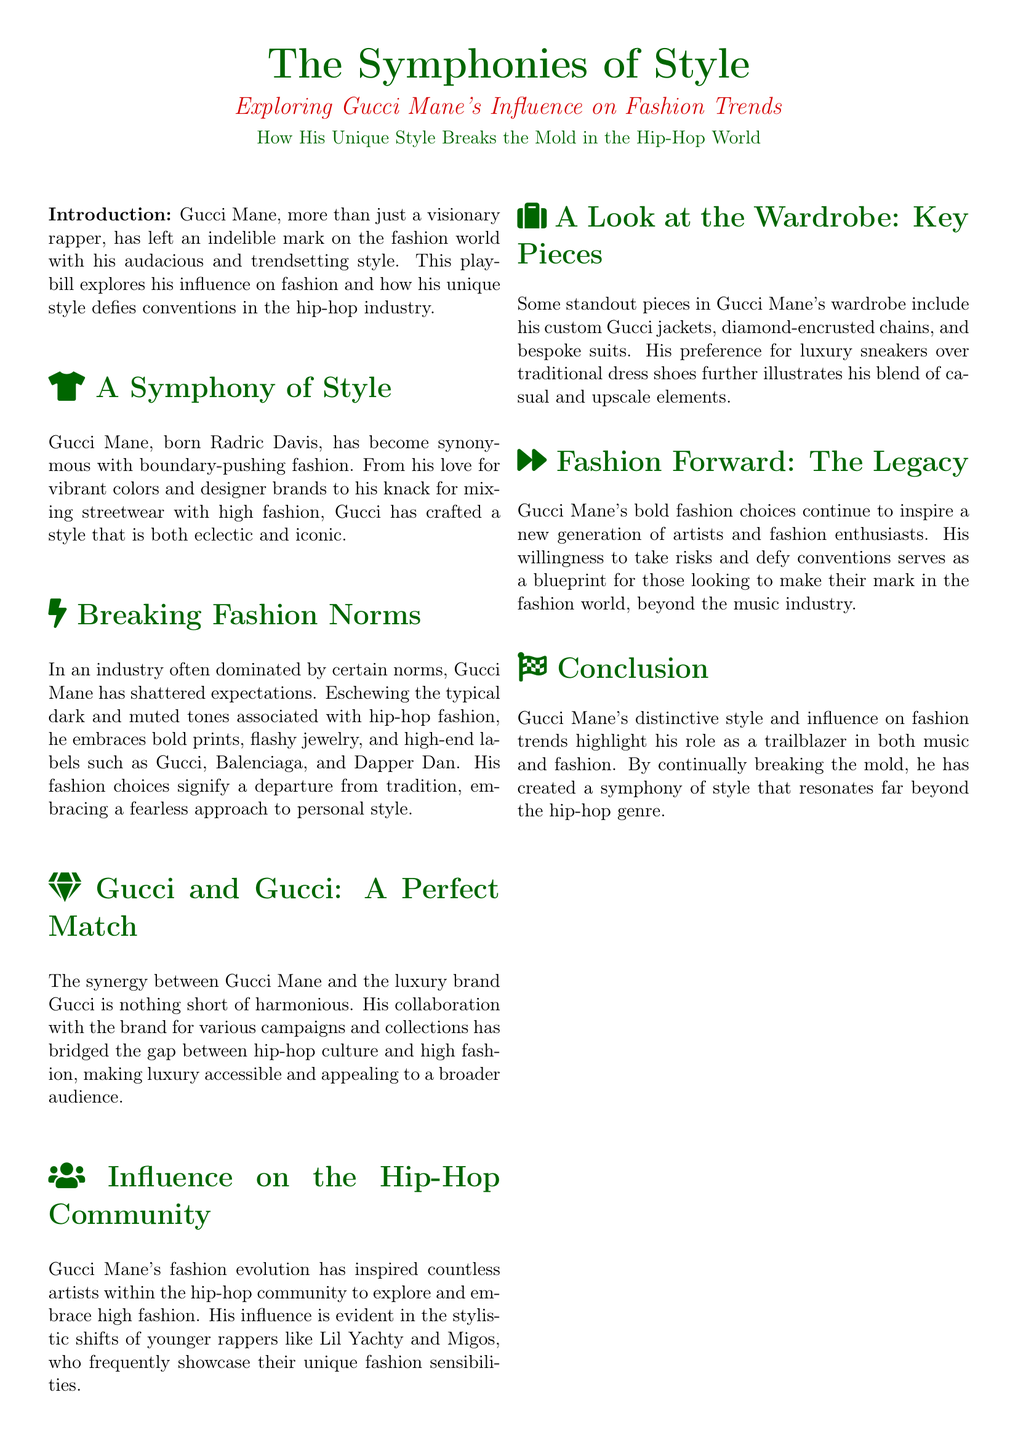what is the title of the playbill? The title of the playbill is prominently displayed at the top of the document as "The Symphonies of Style."
Answer: The Symphonies of Style who is the subject of this playbill? The playbill focuses on Gucci Mane, reflecting on his influence and style in the fashion industry.
Answer: Gucci Mane what colors are associated with the playbill? The document features specific colors related to Gucci Mane, notably green and red.
Answer: green and red what is one high-end label mentioned that Gucci Mane embraces? The playbill lists several brands, highlighting Gucci Mane's affinity for luxury labels in fashion.
Answer: Gucci which younger artists are inspired by Gucci Mane according to the document? The document mentions younger rappers who showcase their unique fashion styles influenced by Gucci Mane.
Answer: Lil Yachty and Migos what is the significance of Gucci Mane's style in the hip-hop community? The playbill discusses how Gucci Mane's fashion has inspired a shift in the aesthetic of the hip-hop community towards high fashion.
Answer: Inspired a shift to high fashion who compiled the research for this playbill? The credits section indicates who was involved in compiling the information for the playbill about Gucci Mane.
Answer: Hip-Hop Fashion Chronicles what type of photography is credited in this document? The playbill recognizes the profession of the photographer featured in the credits.
Answer: hip-hop photographer what is a notable feature of Gucci Mane's wardrobe? The document highlights certain key pieces that define Gucci Mane's unique fashion style, showcasing his wardrobe's characteristics.
Answer: custom Gucci jackets 